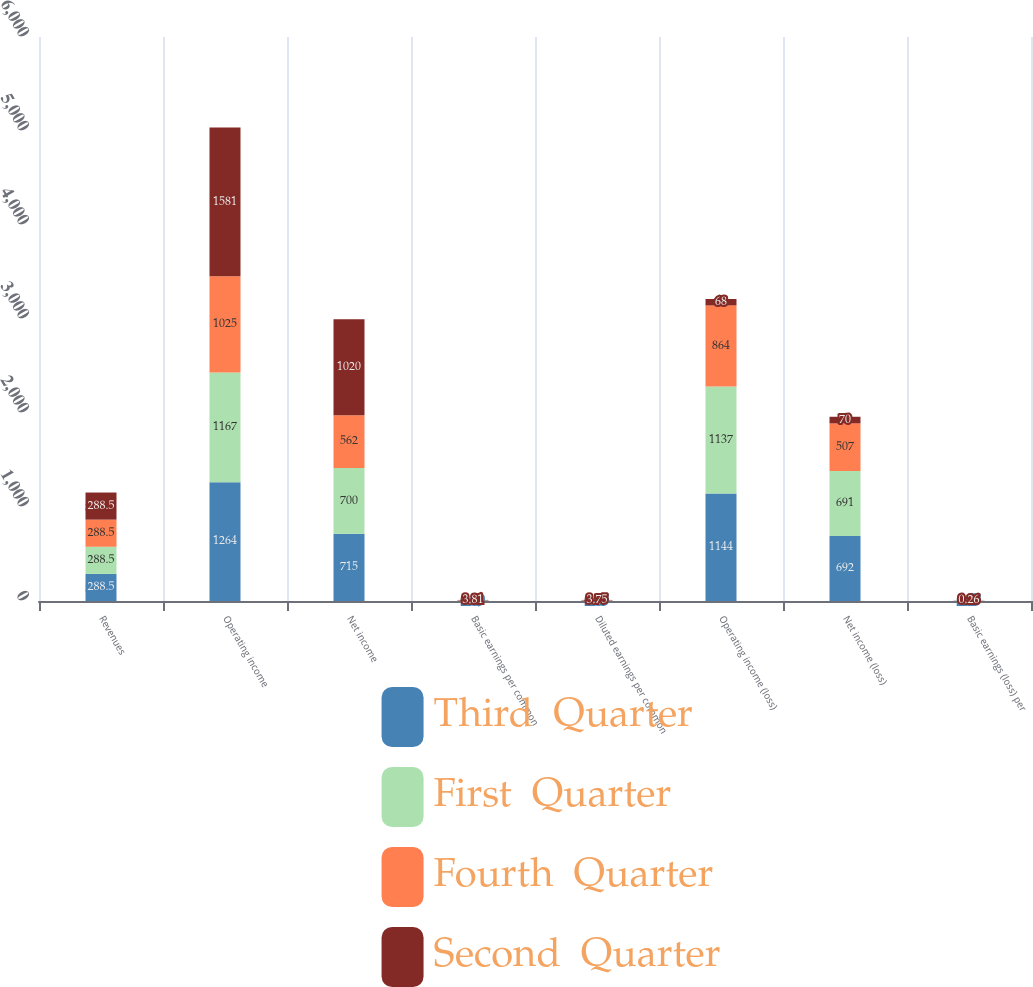<chart> <loc_0><loc_0><loc_500><loc_500><stacked_bar_chart><ecel><fcel>Revenues<fcel>Operating income<fcel>Net income<fcel>Basic earnings per common<fcel>Diluted earnings per common<fcel>Operating income (loss)<fcel>Net income (loss)<fcel>Basic earnings (loss) per<nl><fcel>Third  Quarter<fcel>288.5<fcel>1264<fcel>715<fcel>2.69<fcel>2.65<fcel>1144<fcel>692<fcel>2.45<nl><fcel>First  Quarter<fcel>288.5<fcel>1167<fcel>700<fcel>2.63<fcel>2.59<fcel>1137<fcel>691<fcel>2.47<nl><fcel>Fourth  Quarter<fcel>288.5<fcel>1025<fcel>562<fcel>2.11<fcel>2.07<fcel>864<fcel>507<fcel>1.86<nl><fcel>Second  Quarter<fcel>288.5<fcel>1581<fcel>1020<fcel>3.81<fcel>3.75<fcel>68<fcel>70<fcel>0.26<nl></chart> 